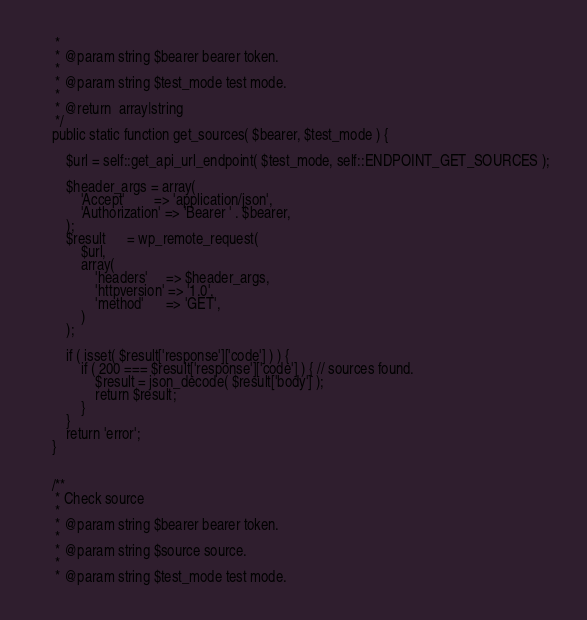Convert code to text. <code><loc_0><loc_0><loc_500><loc_500><_PHP_>	 *
	 * @param string $bearer bearer token.
	 *
	 * @param string $test_mode test mode.
	 *
	 * @return  array|string
	 */
	public static function get_sources( $bearer, $test_mode ) {

		$url = self::get_api_url_endpoint( $test_mode, self::ENDPOINT_GET_SOURCES );

		$header_args = array(
			'Accept'        => 'application/json',
			'Authorization' => 'Bearer ' . $bearer,
		);
		$result      = wp_remote_request(
			$url,
			array(
				'headers'     => $header_args,
				'httpversion' => '1.0',
				'method'      => 'GET',
			)
		);

		if ( isset( $result['response']['code'] ) ) {
			if ( 200 === $result['response']['code'] ) { // sources found.
				$result = json_decode( $result['body'] );
				return $result;
			}
		}
		return 'error';
	}


	/**
	 * Check source
	 *
	 * @param string $bearer bearer token.
	 *
	 * @param string $source source.
	 *
	 * @param string $test_mode test mode.</code> 